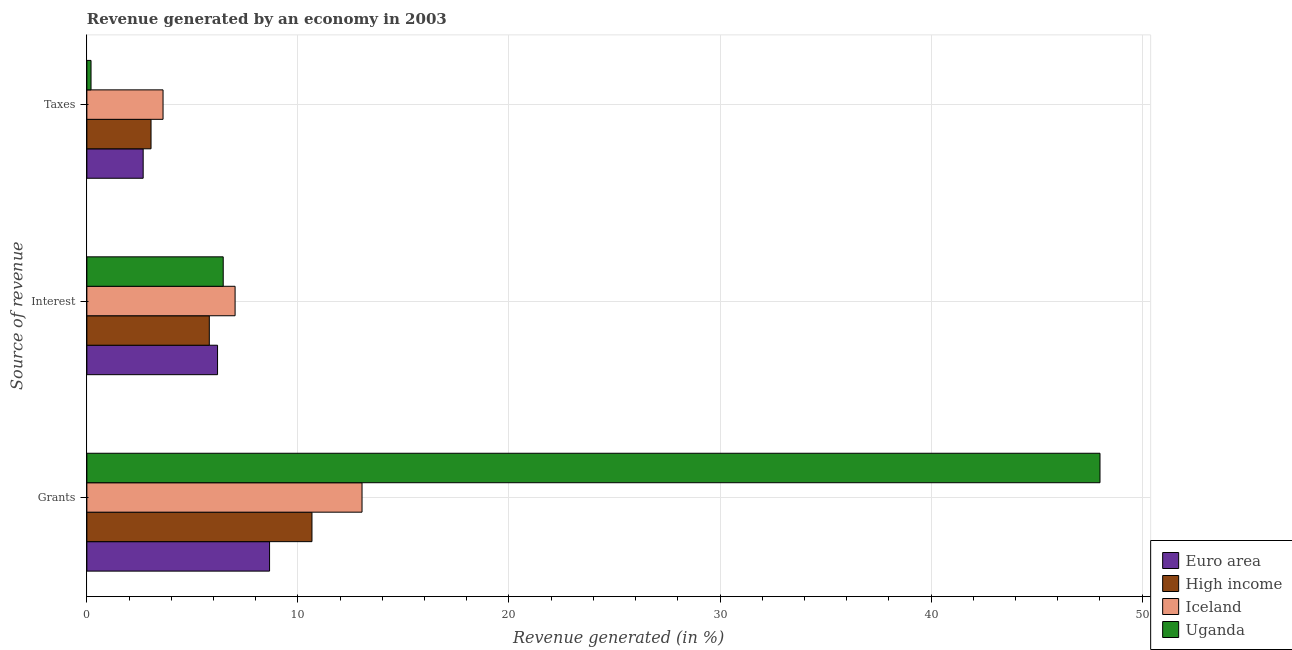How many different coloured bars are there?
Provide a short and direct response. 4. Are the number of bars per tick equal to the number of legend labels?
Your response must be concise. Yes. Are the number of bars on each tick of the Y-axis equal?
Your response must be concise. Yes. How many bars are there on the 3rd tick from the top?
Make the answer very short. 4. What is the label of the 3rd group of bars from the top?
Provide a short and direct response. Grants. What is the percentage of revenue generated by taxes in Uganda?
Give a very brief answer. 0.2. Across all countries, what is the maximum percentage of revenue generated by taxes?
Provide a succinct answer. 3.61. Across all countries, what is the minimum percentage of revenue generated by taxes?
Keep it short and to the point. 0.2. In which country was the percentage of revenue generated by taxes maximum?
Ensure brevity in your answer.  Iceland. In which country was the percentage of revenue generated by grants minimum?
Your response must be concise. Euro area. What is the total percentage of revenue generated by taxes in the graph?
Provide a succinct answer. 9.51. What is the difference between the percentage of revenue generated by interest in Euro area and that in Iceland?
Ensure brevity in your answer.  -0.83. What is the difference between the percentage of revenue generated by grants in High income and the percentage of revenue generated by taxes in Euro area?
Provide a succinct answer. 8. What is the average percentage of revenue generated by taxes per country?
Give a very brief answer. 2.38. What is the difference between the percentage of revenue generated by grants and percentage of revenue generated by interest in Euro area?
Keep it short and to the point. 2.46. In how many countries, is the percentage of revenue generated by interest greater than 18 %?
Offer a very short reply. 0. What is the ratio of the percentage of revenue generated by grants in Iceland to that in High income?
Make the answer very short. 1.22. Is the percentage of revenue generated by grants in Uganda less than that in Iceland?
Give a very brief answer. No. Is the difference between the percentage of revenue generated by taxes in Iceland and Euro area greater than the difference between the percentage of revenue generated by grants in Iceland and Euro area?
Your response must be concise. No. What is the difference between the highest and the second highest percentage of revenue generated by interest?
Give a very brief answer. 0.56. What is the difference between the highest and the lowest percentage of revenue generated by interest?
Give a very brief answer. 1.22. In how many countries, is the percentage of revenue generated by taxes greater than the average percentage of revenue generated by taxes taken over all countries?
Offer a very short reply. 3. Is the sum of the percentage of revenue generated by interest in High income and Euro area greater than the maximum percentage of revenue generated by taxes across all countries?
Your answer should be compact. Yes. What does the 3rd bar from the top in Grants represents?
Ensure brevity in your answer.  High income. Is it the case that in every country, the sum of the percentage of revenue generated by grants and percentage of revenue generated by interest is greater than the percentage of revenue generated by taxes?
Your response must be concise. Yes. Are all the bars in the graph horizontal?
Your answer should be compact. Yes. What is the difference between two consecutive major ticks on the X-axis?
Your answer should be compact. 10. Does the graph contain any zero values?
Your answer should be compact. No. Does the graph contain grids?
Give a very brief answer. Yes. Where does the legend appear in the graph?
Your response must be concise. Bottom right. How many legend labels are there?
Provide a short and direct response. 4. What is the title of the graph?
Your answer should be very brief. Revenue generated by an economy in 2003. What is the label or title of the X-axis?
Provide a succinct answer. Revenue generated (in %). What is the label or title of the Y-axis?
Your answer should be very brief. Source of revenue. What is the Revenue generated (in %) of Euro area in Grants?
Offer a very short reply. 8.66. What is the Revenue generated (in %) of High income in Grants?
Offer a terse response. 10.67. What is the Revenue generated (in %) of Iceland in Grants?
Your answer should be compact. 13.04. What is the Revenue generated (in %) in Uganda in Grants?
Your answer should be compact. 48.01. What is the Revenue generated (in %) of Euro area in Interest?
Offer a very short reply. 6.19. What is the Revenue generated (in %) in High income in Interest?
Your answer should be very brief. 5.8. What is the Revenue generated (in %) in Iceland in Interest?
Your response must be concise. 7.02. What is the Revenue generated (in %) of Uganda in Interest?
Offer a very short reply. 6.46. What is the Revenue generated (in %) in Euro area in Taxes?
Provide a succinct answer. 2.67. What is the Revenue generated (in %) of High income in Taxes?
Your answer should be very brief. 3.04. What is the Revenue generated (in %) of Iceland in Taxes?
Your answer should be very brief. 3.61. What is the Revenue generated (in %) in Uganda in Taxes?
Give a very brief answer. 0.2. Across all Source of revenue, what is the maximum Revenue generated (in %) in Euro area?
Offer a very short reply. 8.66. Across all Source of revenue, what is the maximum Revenue generated (in %) of High income?
Make the answer very short. 10.67. Across all Source of revenue, what is the maximum Revenue generated (in %) in Iceland?
Your answer should be very brief. 13.04. Across all Source of revenue, what is the maximum Revenue generated (in %) of Uganda?
Offer a very short reply. 48.01. Across all Source of revenue, what is the minimum Revenue generated (in %) in Euro area?
Provide a short and direct response. 2.67. Across all Source of revenue, what is the minimum Revenue generated (in %) of High income?
Provide a short and direct response. 3.04. Across all Source of revenue, what is the minimum Revenue generated (in %) of Iceland?
Keep it short and to the point. 3.61. Across all Source of revenue, what is the minimum Revenue generated (in %) in Uganda?
Your answer should be very brief. 0.2. What is the total Revenue generated (in %) of Euro area in the graph?
Make the answer very short. 17.52. What is the total Revenue generated (in %) of High income in the graph?
Give a very brief answer. 19.51. What is the total Revenue generated (in %) of Iceland in the graph?
Ensure brevity in your answer.  23.67. What is the total Revenue generated (in %) in Uganda in the graph?
Keep it short and to the point. 54.66. What is the difference between the Revenue generated (in %) of Euro area in Grants and that in Interest?
Offer a very short reply. 2.46. What is the difference between the Revenue generated (in %) of High income in Grants and that in Interest?
Ensure brevity in your answer.  4.86. What is the difference between the Revenue generated (in %) of Iceland in Grants and that in Interest?
Provide a succinct answer. 6.01. What is the difference between the Revenue generated (in %) in Uganda in Grants and that in Interest?
Ensure brevity in your answer.  41.54. What is the difference between the Revenue generated (in %) in Euro area in Grants and that in Taxes?
Offer a very short reply. 5.99. What is the difference between the Revenue generated (in %) of High income in Grants and that in Taxes?
Give a very brief answer. 7.63. What is the difference between the Revenue generated (in %) in Iceland in Grants and that in Taxes?
Your response must be concise. 9.43. What is the difference between the Revenue generated (in %) of Uganda in Grants and that in Taxes?
Give a very brief answer. 47.81. What is the difference between the Revenue generated (in %) of Euro area in Interest and that in Taxes?
Ensure brevity in your answer.  3.52. What is the difference between the Revenue generated (in %) in High income in Interest and that in Taxes?
Make the answer very short. 2.76. What is the difference between the Revenue generated (in %) of Iceland in Interest and that in Taxes?
Make the answer very short. 3.41. What is the difference between the Revenue generated (in %) in Uganda in Interest and that in Taxes?
Give a very brief answer. 6.26. What is the difference between the Revenue generated (in %) of Euro area in Grants and the Revenue generated (in %) of High income in Interest?
Give a very brief answer. 2.86. What is the difference between the Revenue generated (in %) of Euro area in Grants and the Revenue generated (in %) of Iceland in Interest?
Give a very brief answer. 1.63. What is the difference between the Revenue generated (in %) in Euro area in Grants and the Revenue generated (in %) in Uganda in Interest?
Your answer should be compact. 2.2. What is the difference between the Revenue generated (in %) of High income in Grants and the Revenue generated (in %) of Iceland in Interest?
Keep it short and to the point. 3.64. What is the difference between the Revenue generated (in %) of High income in Grants and the Revenue generated (in %) of Uganda in Interest?
Keep it short and to the point. 4.21. What is the difference between the Revenue generated (in %) in Iceland in Grants and the Revenue generated (in %) in Uganda in Interest?
Your answer should be compact. 6.58. What is the difference between the Revenue generated (in %) in Euro area in Grants and the Revenue generated (in %) in High income in Taxes?
Your response must be concise. 5.62. What is the difference between the Revenue generated (in %) in Euro area in Grants and the Revenue generated (in %) in Iceland in Taxes?
Provide a short and direct response. 5.05. What is the difference between the Revenue generated (in %) in Euro area in Grants and the Revenue generated (in %) in Uganda in Taxes?
Provide a succinct answer. 8.46. What is the difference between the Revenue generated (in %) in High income in Grants and the Revenue generated (in %) in Iceland in Taxes?
Your answer should be compact. 7.06. What is the difference between the Revenue generated (in %) of High income in Grants and the Revenue generated (in %) of Uganda in Taxes?
Offer a very short reply. 10.47. What is the difference between the Revenue generated (in %) in Iceland in Grants and the Revenue generated (in %) in Uganda in Taxes?
Your response must be concise. 12.84. What is the difference between the Revenue generated (in %) in Euro area in Interest and the Revenue generated (in %) in High income in Taxes?
Make the answer very short. 3.15. What is the difference between the Revenue generated (in %) of Euro area in Interest and the Revenue generated (in %) of Iceland in Taxes?
Offer a terse response. 2.58. What is the difference between the Revenue generated (in %) of Euro area in Interest and the Revenue generated (in %) of Uganda in Taxes?
Keep it short and to the point. 6. What is the difference between the Revenue generated (in %) in High income in Interest and the Revenue generated (in %) in Iceland in Taxes?
Make the answer very short. 2.19. What is the difference between the Revenue generated (in %) of High income in Interest and the Revenue generated (in %) of Uganda in Taxes?
Keep it short and to the point. 5.6. What is the difference between the Revenue generated (in %) of Iceland in Interest and the Revenue generated (in %) of Uganda in Taxes?
Your answer should be compact. 6.83. What is the average Revenue generated (in %) of Euro area per Source of revenue?
Your answer should be compact. 5.84. What is the average Revenue generated (in %) of High income per Source of revenue?
Ensure brevity in your answer.  6.5. What is the average Revenue generated (in %) in Iceland per Source of revenue?
Your answer should be compact. 7.89. What is the average Revenue generated (in %) in Uganda per Source of revenue?
Your response must be concise. 18.22. What is the difference between the Revenue generated (in %) of Euro area and Revenue generated (in %) of High income in Grants?
Offer a terse response. -2.01. What is the difference between the Revenue generated (in %) in Euro area and Revenue generated (in %) in Iceland in Grants?
Keep it short and to the point. -4.38. What is the difference between the Revenue generated (in %) of Euro area and Revenue generated (in %) of Uganda in Grants?
Provide a short and direct response. -39.35. What is the difference between the Revenue generated (in %) of High income and Revenue generated (in %) of Iceland in Grants?
Your response must be concise. -2.37. What is the difference between the Revenue generated (in %) in High income and Revenue generated (in %) in Uganda in Grants?
Give a very brief answer. -37.34. What is the difference between the Revenue generated (in %) in Iceland and Revenue generated (in %) in Uganda in Grants?
Offer a terse response. -34.97. What is the difference between the Revenue generated (in %) of Euro area and Revenue generated (in %) of High income in Interest?
Your answer should be compact. 0.39. What is the difference between the Revenue generated (in %) in Euro area and Revenue generated (in %) in Iceland in Interest?
Provide a succinct answer. -0.83. What is the difference between the Revenue generated (in %) of Euro area and Revenue generated (in %) of Uganda in Interest?
Your answer should be very brief. -0.27. What is the difference between the Revenue generated (in %) in High income and Revenue generated (in %) in Iceland in Interest?
Keep it short and to the point. -1.22. What is the difference between the Revenue generated (in %) in High income and Revenue generated (in %) in Uganda in Interest?
Provide a short and direct response. -0.66. What is the difference between the Revenue generated (in %) in Iceland and Revenue generated (in %) in Uganda in Interest?
Offer a very short reply. 0.56. What is the difference between the Revenue generated (in %) in Euro area and Revenue generated (in %) in High income in Taxes?
Offer a very short reply. -0.37. What is the difference between the Revenue generated (in %) in Euro area and Revenue generated (in %) in Iceland in Taxes?
Ensure brevity in your answer.  -0.94. What is the difference between the Revenue generated (in %) in Euro area and Revenue generated (in %) in Uganda in Taxes?
Your response must be concise. 2.47. What is the difference between the Revenue generated (in %) of High income and Revenue generated (in %) of Iceland in Taxes?
Ensure brevity in your answer.  -0.57. What is the difference between the Revenue generated (in %) in High income and Revenue generated (in %) in Uganda in Taxes?
Keep it short and to the point. 2.84. What is the difference between the Revenue generated (in %) in Iceland and Revenue generated (in %) in Uganda in Taxes?
Your response must be concise. 3.41. What is the ratio of the Revenue generated (in %) of Euro area in Grants to that in Interest?
Ensure brevity in your answer.  1.4. What is the ratio of the Revenue generated (in %) of High income in Grants to that in Interest?
Give a very brief answer. 1.84. What is the ratio of the Revenue generated (in %) in Iceland in Grants to that in Interest?
Ensure brevity in your answer.  1.86. What is the ratio of the Revenue generated (in %) of Uganda in Grants to that in Interest?
Give a very brief answer. 7.43. What is the ratio of the Revenue generated (in %) in Euro area in Grants to that in Taxes?
Provide a short and direct response. 3.25. What is the ratio of the Revenue generated (in %) of High income in Grants to that in Taxes?
Provide a succinct answer. 3.51. What is the ratio of the Revenue generated (in %) in Iceland in Grants to that in Taxes?
Provide a succinct answer. 3.61. What is the ratio of the Revenue generated (in %) in Uganda in Grants to that in Taxes?
Give a very brief answer. 244.11. What is the ratio of the Revenue generated (in %) of Euro area in Interest to that in Taxes?
Offer a very short reply. 2.32. What is the ratio of the Revenue generated (in %) of High income in Interest to that in Taxes?
Provide a short and direct response. 1.91. What is the ratio of the Revenue generated (in %) of Iceland in Interest to that in Taxes?
Your answer should be very brief. 1.95. What is the ratio of the Revenue generated (in %) in Uganda in Interest to that in Taxes?
Ensure brevity in your answer.  32.85. What is the difference between the highest and the second highest Revenue generated (in %) in Euro area?
Your answer should be very brief. 2.46. What is the difference between the highest and the second highest Revenue generated (in %) in High income?
Keep it short and to the point. 4.86. What is the difference between the highest and the second highest Revenue generated (in %) in Iceland?
Give a very brief answer. 6.01. What is the difference between the highest and the second highest Revenue generated (in %) of Uganda?
Your response must be concise. 41.54. What is the difference between the highest and the lowest Revenue generated (in %) of Euro area?
Your answer should be compact. 5.99. What is the difference between the highest and the lowest Revenue generated (in %) in High income?
Your answer should be very brief. 7.63. What is the difference between the highest and the lowest Revenue generated (in %) of Iceland?
Provide a succinct answer. 9.43. What is the difference between the highest and the lowest Revenue generated (in %) of Uganda?
Offer a terse response. 47.81. 